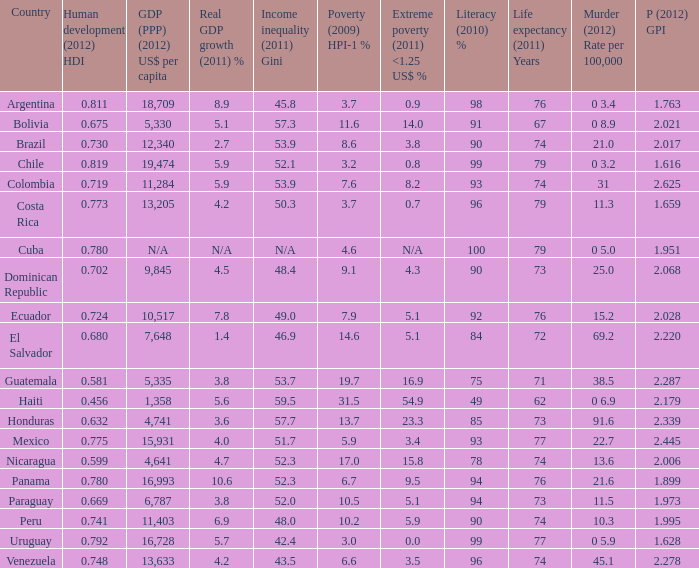What murder (2012) rate per 100,00 also has a 1.616 as the peace (2012) GPI? 0 3.2. 